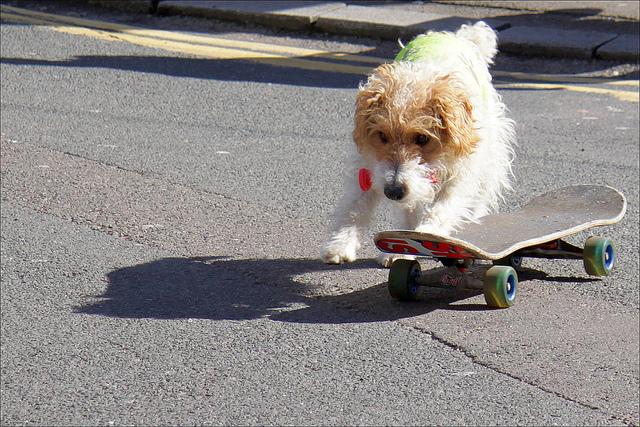What is the dog playing with?
Short answer required. Skateboard. What is the dog playing with?
Quick response, please. Skateboard. Where is the dog playing with the skateboard?
Quick response, please. Street. 